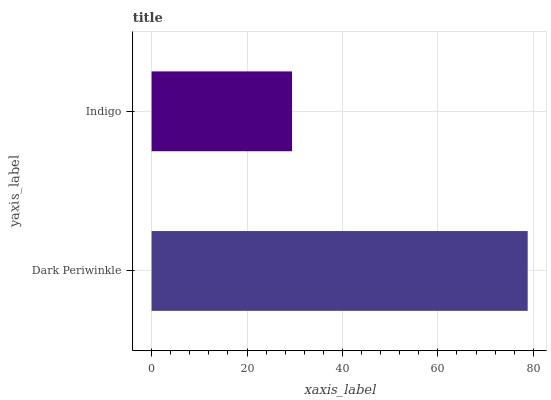Is Indigo the minimum?
Answer yes or no. Yes. Is Dark Periwinkle the maximum?
Answer yes or no. Yes. Is Indigo the maximum?
Answer yes or no. No. Is Dark Periwinkle greater than Indigo?
Answer yes or no. Yes. Is Indigo less than Dark Periwinkle?
Answer yes or no. Yes. Is Indigo greater than Dark Periwinkle?
Answer yes or no. No. Is Dark Periwinkle less than Indigo?
Answer yes or no. No. Is Dark Periwinkle the high median?
Answer yes or no. Yes. Is Indigo the low median?
Answer yes or no. Yes. Is Indigo the high median?
Answer yes or no. No. Is Dark Periwinkle the low median?
Answer yes or no. No. 